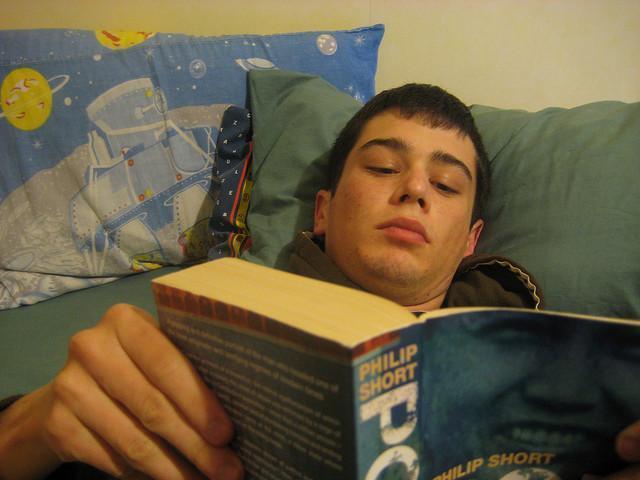What is the boy doing with the book?
Answer the question by selecting the correct answer among the 4 following choices.
Options: Highlighting it, tearing it, burning it, reading it. Reading it. 